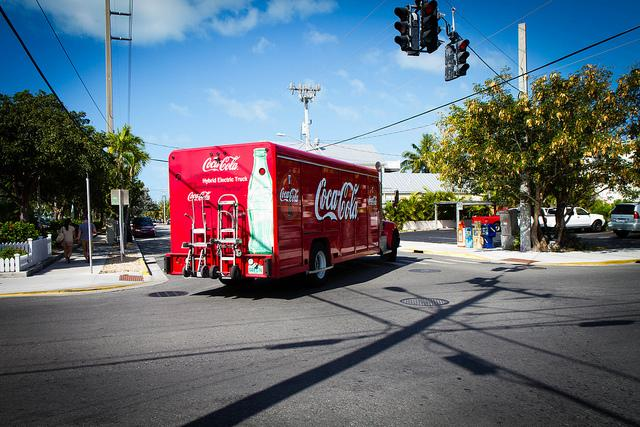Where is the truck going? Please explain your reasoning. store. The truck holds coca cola bottles which are sold at a store. 